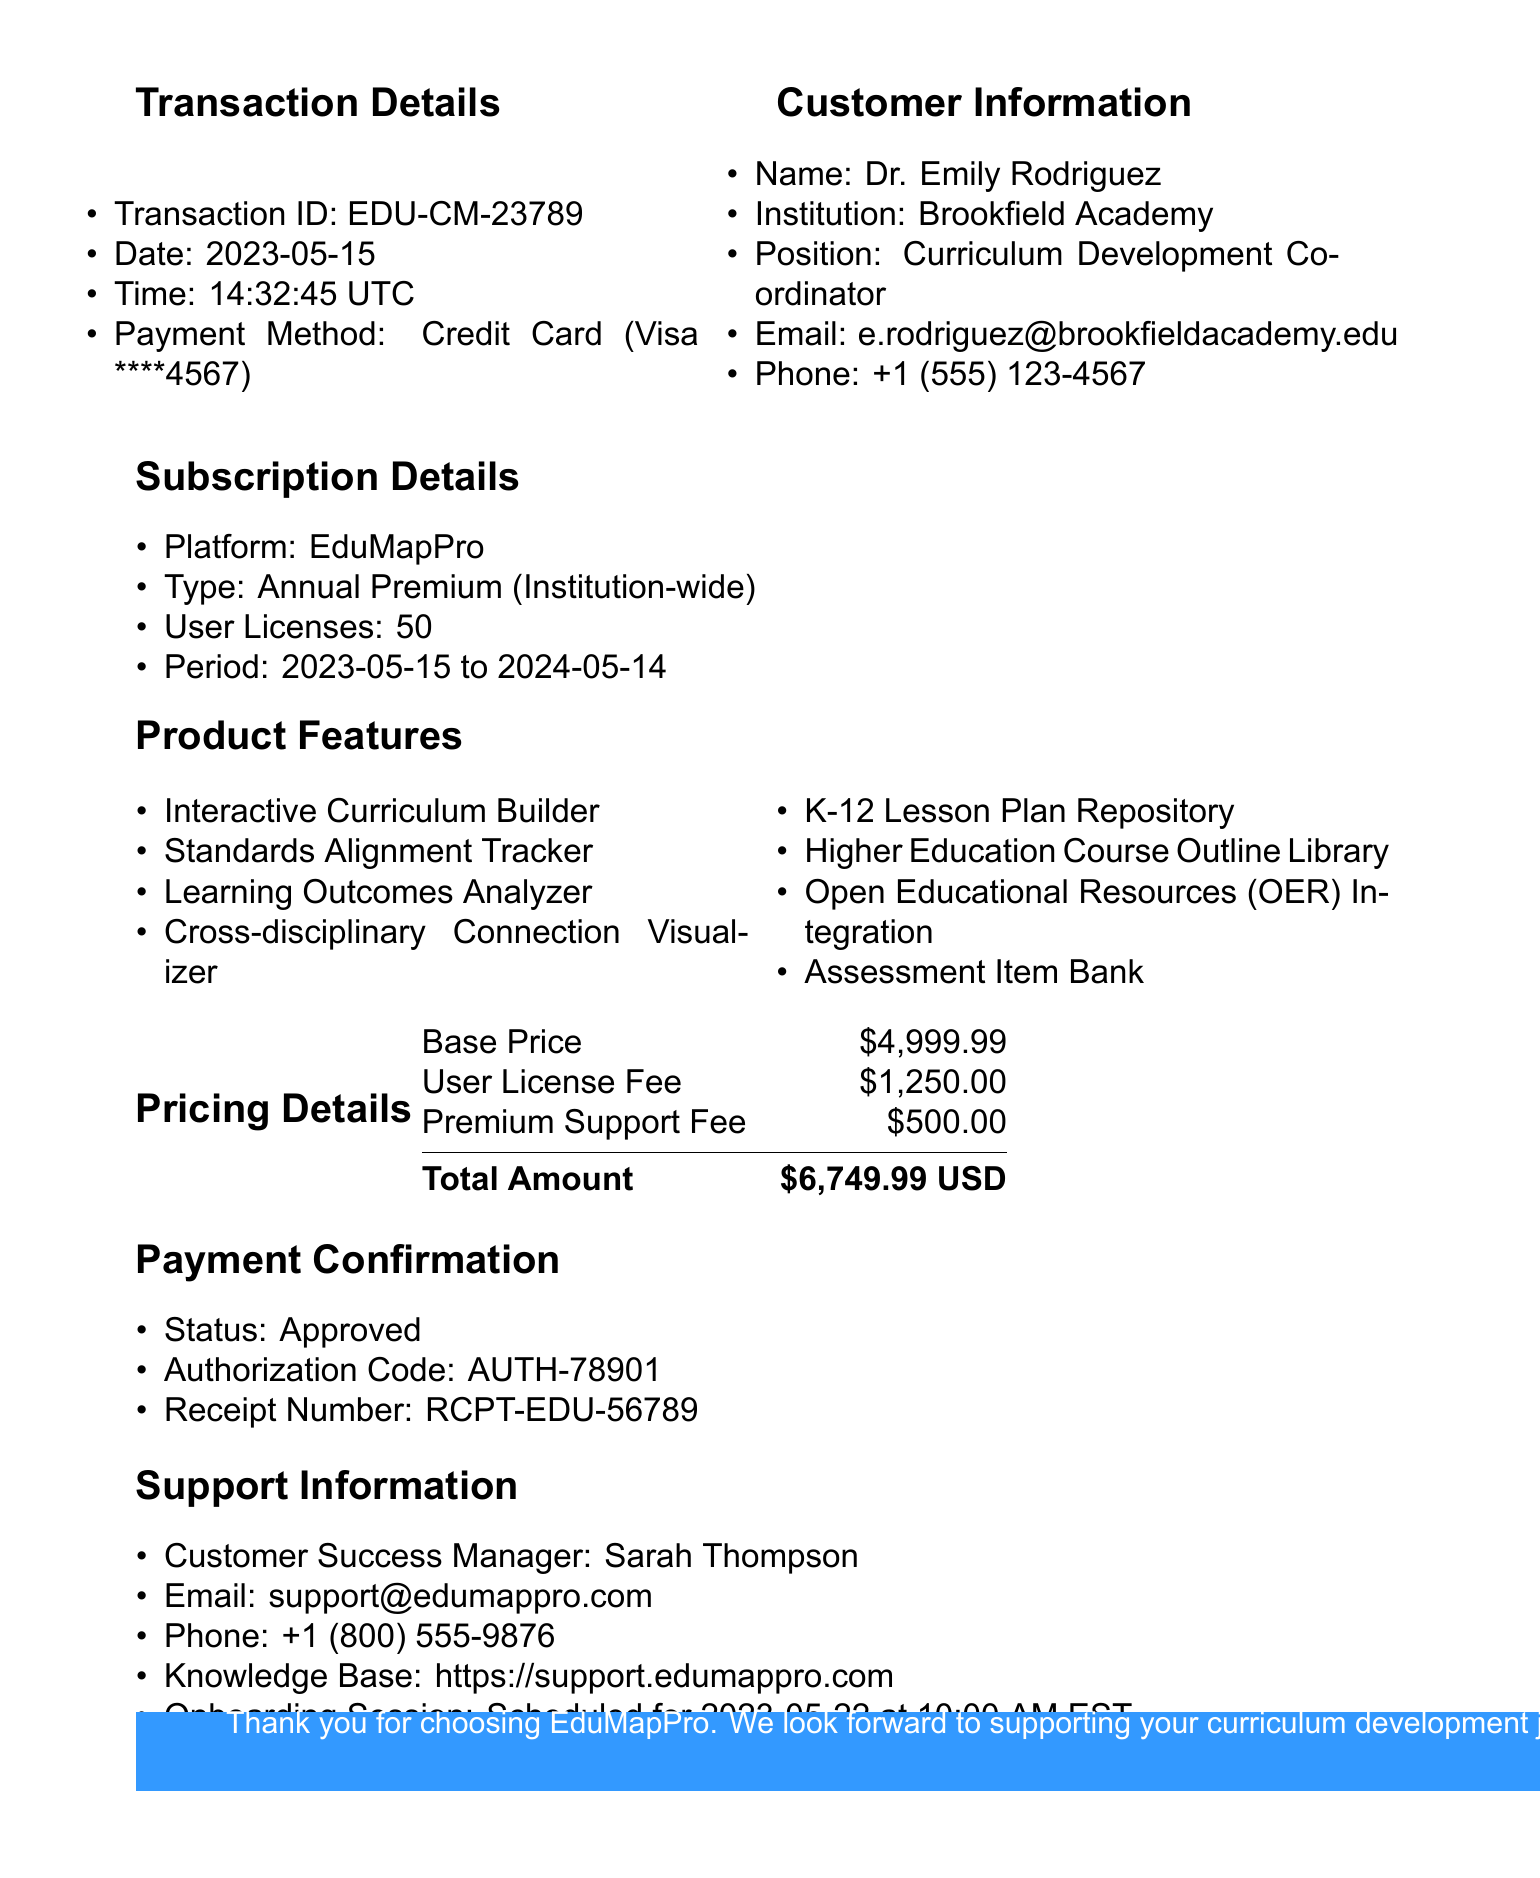What is the transaction ID? The transaction ID is specifically mentioned under transaction details as EDU-CM-23789.
Answer: EDU-CM-23789 What date was the transaction made? The date of the transaction is explicitly stated as 2023-05-15 in the transaction details section.
Answer: 2023-05-15 How many user licenses were included in the subscription? The number of user licenses is a detail found in the subscription details, which states there are 50 user licenses.
Answer: 50 What is the total amount charged for the subscription? The total amount is summarized in the pricing section as $6,749.99.
Answer: $6,749.99 Who is the customer success manager? The customer success manager's name is provided in the support information section as Sarah Thompson.
Answer: Sarah Thompson What features support collaborative efforts in the product? Features that support collaboration are listed under additional tools, including Collaborative Workspace and Professional Development Tracker.
Answer: Collaborative Workspace, Professional Development Tracker What type of subscription was purchased? The document states that the subscription type is Annual Premium, which is found in the subscription details.
Answer: Annual Premium When is the onboarding session scheduled? The onboarding session date is stated in the support information as scheduled for 2023-05-22 at 10:00 AM EST.
Answer: 2023-05-22 at 10:00 AM EST What is the authorization code for this transaction? The authorization code is specified under payment confirmation as AUTH-78901.
Answer: AUTH-78901 